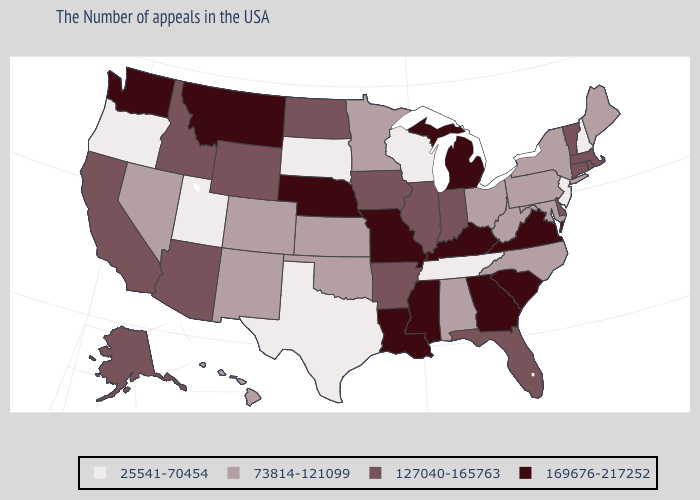Which states have the lowest value in the South?
Short answer required. Tennessee, Texas. Name the states that have a value in the range 25541-70454?
Quick response, please. New Hampshire, New Jersey, Tennessee, Wisconsin, Texas, South Dakota, Utah, Oregon. Does Arizona have the same value as Alaska?
Quick response, please. Yes. Does the first symbol in the legend represent the smallest category?
Concise answer only. Yes. What is the lowest value in the South?
Answer briefly. 25541-70454. What is the value of Arkansas?
Answer briefly. 127040-165763. Is the legend a continuous bar?
Give a very brief answer. No. Name the states that have a value in the range 127040-165763?
Answer briefly. Massachusetts, Rhode Island, Vermont, Connecticut, Delaware, Florida, Indiana, Illinois, Arkansas, Iowa, North Dakota, Wyoming, Arizona, Idaho, California, Alaska. Name the states that have a value in the range 25541-70454?
Be succinct. New Hampshire, New Jersey, Tennessee, Wisconsin, Texas, South Dakota, Utah, Oregon. What is the highest value in states that border Oklahoma?
Be succinct. 169676-217252. How many symbols are there in the legend?
Be succinct. 4. What is the value of New Jersey?
Write a very short answer. 25541-70454. Name the states that have a value in the range 73814-121099?
Be succinct. Maine, New York, Maryland, Pennsylvania, North Carolina, West Virginia, Ohio, Alabama, Minnesota, Kansas, Oklahoma, Colorado, New Mexico, Nevada, Hawaii. Name the states that have a value in the range 169676-217252?
Concise answer only. Virginia, South Carolina, Georgia, Michigan, Kentucky, Mississippi, Louisiana, Missouri, Nebraska, Montana, Washington. What is the highest value in the South ?
Concise answer only. 169676-217252. 